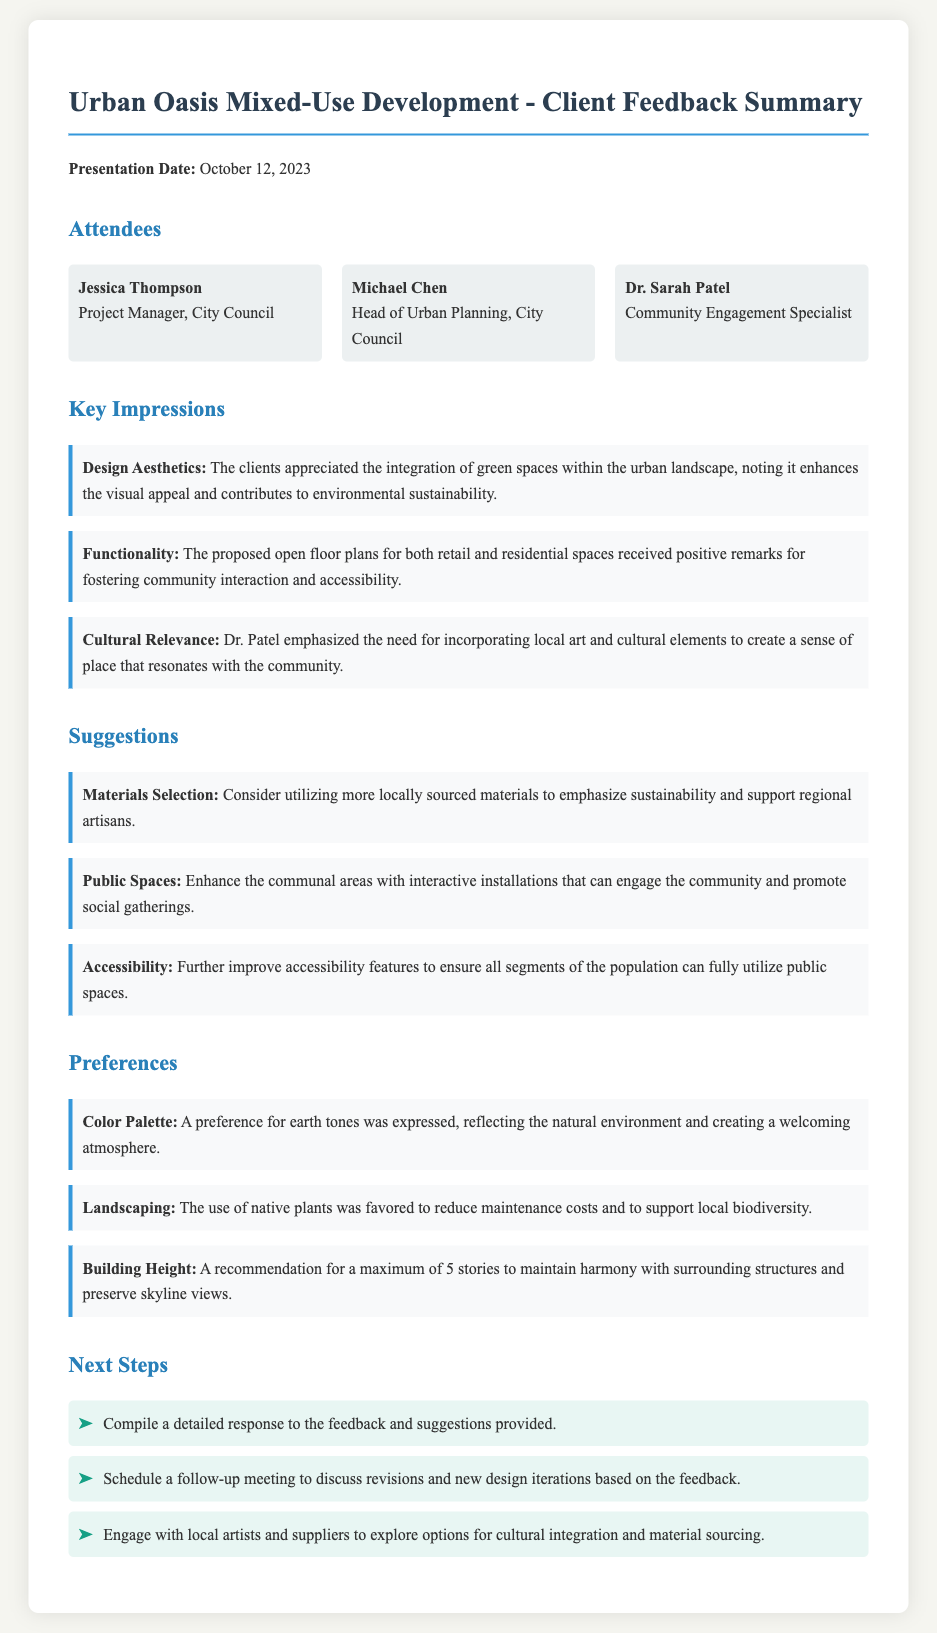What is the presentation date? The presentation date is mentioned in the memo as a specific date, which is October 12, 2023.
Answer: October 12, 2023 Who is the Head of Urban Planning? The memo lists individuals who attended the presentation, specifically identifying the Head of Urban Planning as Michael Chen.
Answer: Michael Chen What aspect of the design received positive remarks for functionality? The memo indicates that the proposed open floor plans for both retail and residential spaces were appreciated for fostering community interaction and accessibility.
Answer: Open floor plans What suggestion was made regarding materials selection? The memo suggests utilizing more locally sourced materials to emphasize sustainability and support regional artisans.
Answer: Locally sourced materials What color palette preference was expressed? The memo notes a preference for earth tones to reflect the natural environment and create a welcoming atmosphere.
Answer: Earth tones Who emphasized the need for incorporating local art and cultural elements? The memo refers to Dr. Sarah Patel as the individual who highlighted the importance of integrating local art and cultural elements into the design.
Answer: Dr. Sarah Patel What was the recommendation regarding building height? The document recommends a maximum building height of 5 stories to maintain a balance with surrounding structures and skyline views.
Answer: 5 stories What is listed as a next step in the feedback process? The memo outlines the next steps, including compiling a detailed response to the feedback and suggestions provided.
Answer: Compile a detailed response 